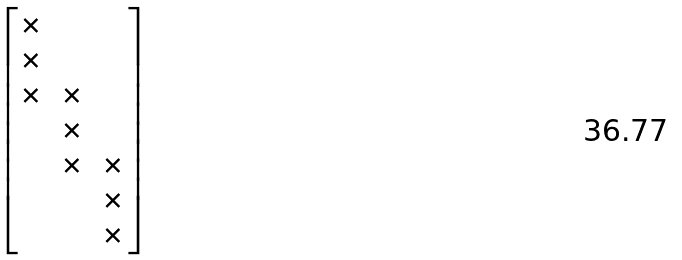Convert formula to latex. <formula><loc_0><loc_0><loc_500><loc_500>\begin{bmatrix} \times & & \\ \times & & \\ \times & \times & \\ & \times & \\ & \times & \times \\ & & \times \\ & & \times \end{bmatrix}</formula> 